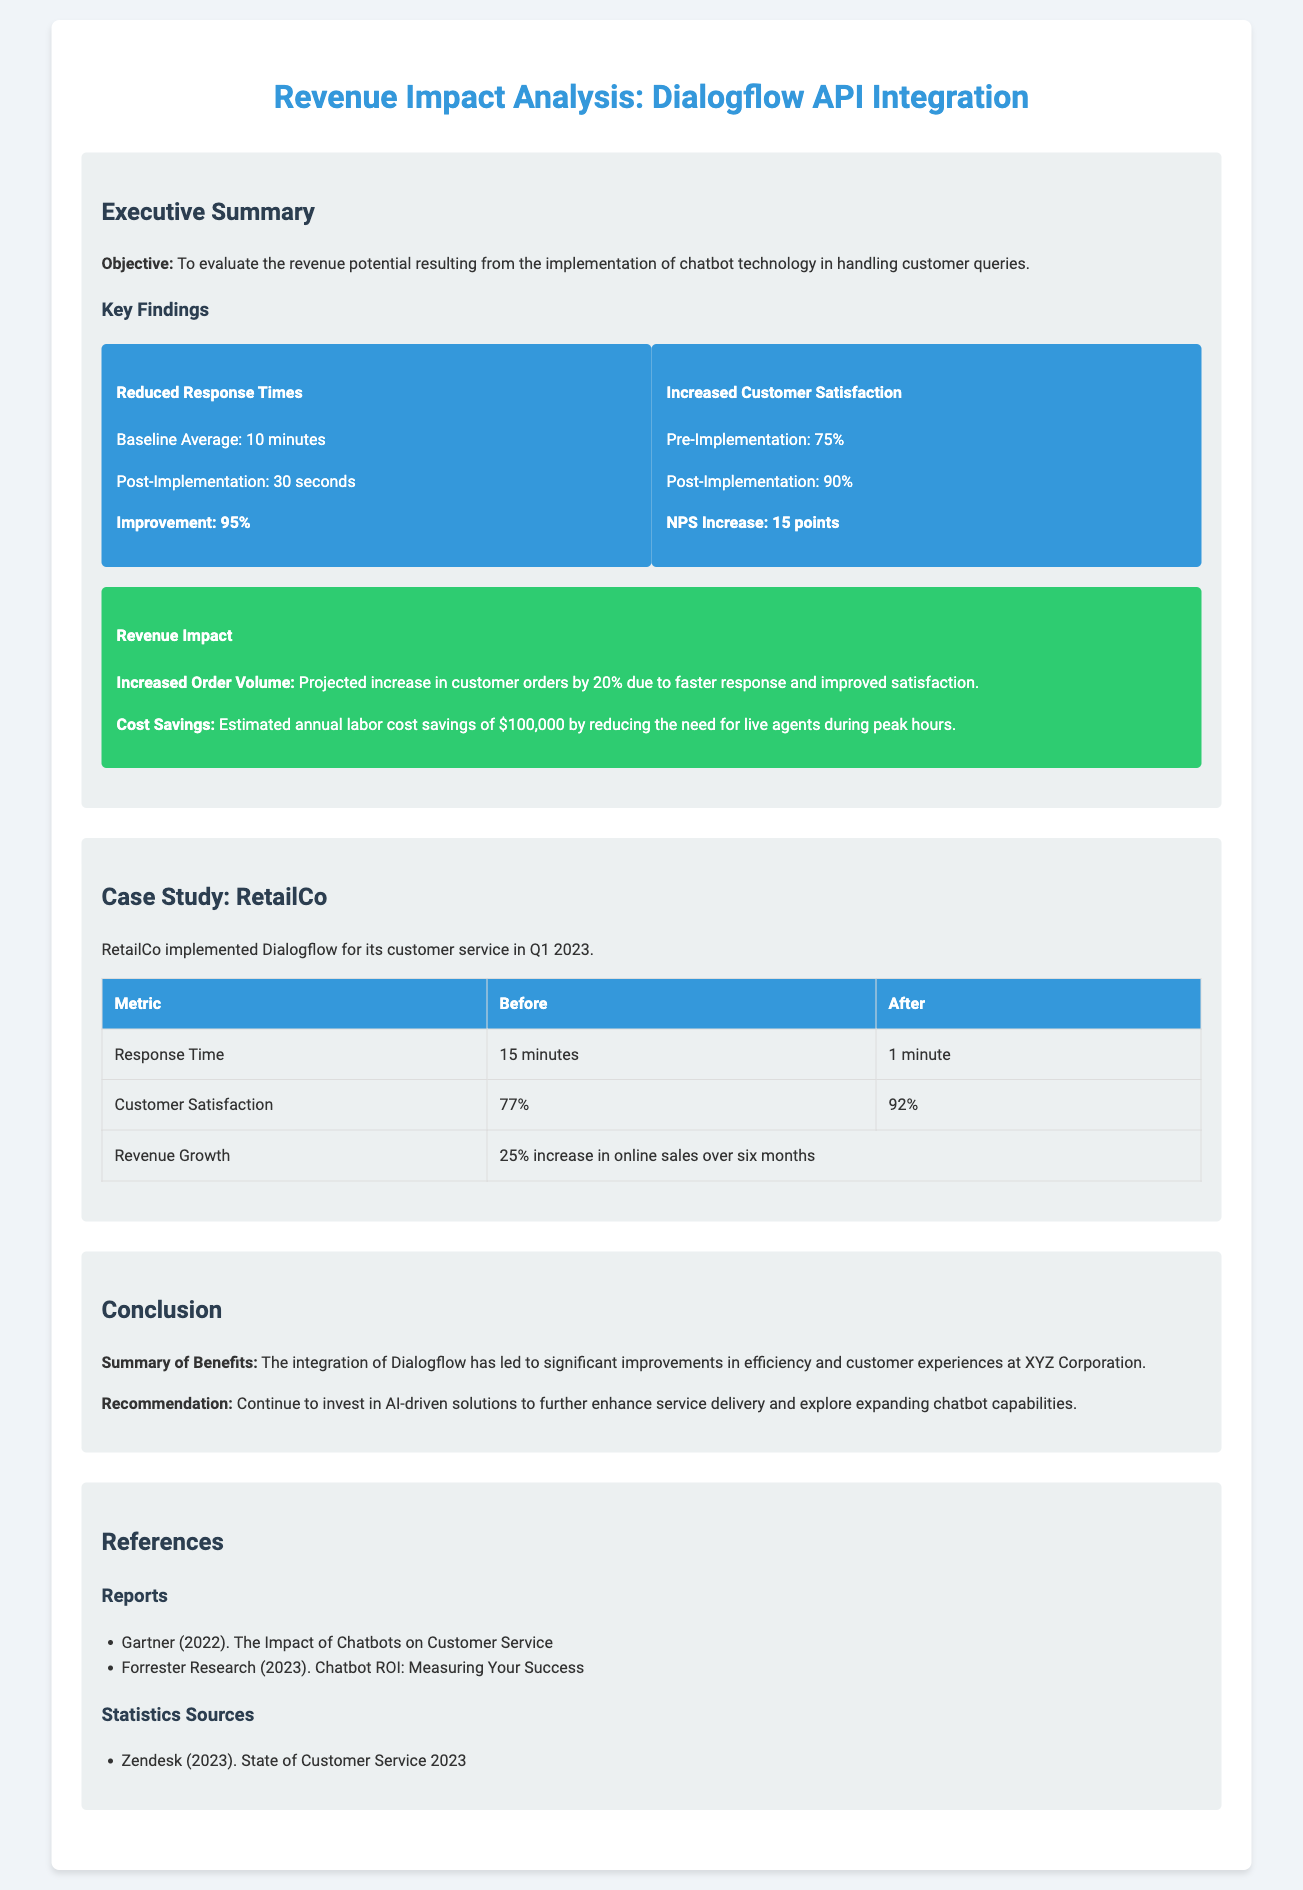what is the baseline average response time? The document states that the baseline average response time is 10 minutes.
Answer: 10 minutes what is the post-implementation response time? According to the key findings, the post-implementation response time is 30 seconds.
Answer: 30 seconds what was the customer satisfaction rate pre-implementation? The pre-implementation customer satisfaction rate is mentioned as 75%.
Answer: 75% how much cost savings does the chatbot implementation provide annually? The estimated annual labor cost savings mentioned is $100,000.
Answer: $100,000 what was the average response time for RetailCo before implementation? The average response time for RetailCo before implementation is stated as 15 minutes.
Answer: 15 minutes what is the NPS increase reported after chatbot implementation? The document highlights that the Net Promoter Score (NPS) increased by 15 points post-implementation.
Answer: 15 points which company implemented Dialogflow in Q1 2023? The case study indicates that RetailCo implemented Dialogflow in Q1 2023.
Answer: RetailCo what percentage increase in online sales did RetailCo experience? The document reports a 25% increase in online sales for RetailCo over six months.
Answer: 25% what is the objective of the revenue impact analysis? The objective is to evaluate the revenue potential from implementing chatbot technology.
Answer: Evaluate the revenue potential 